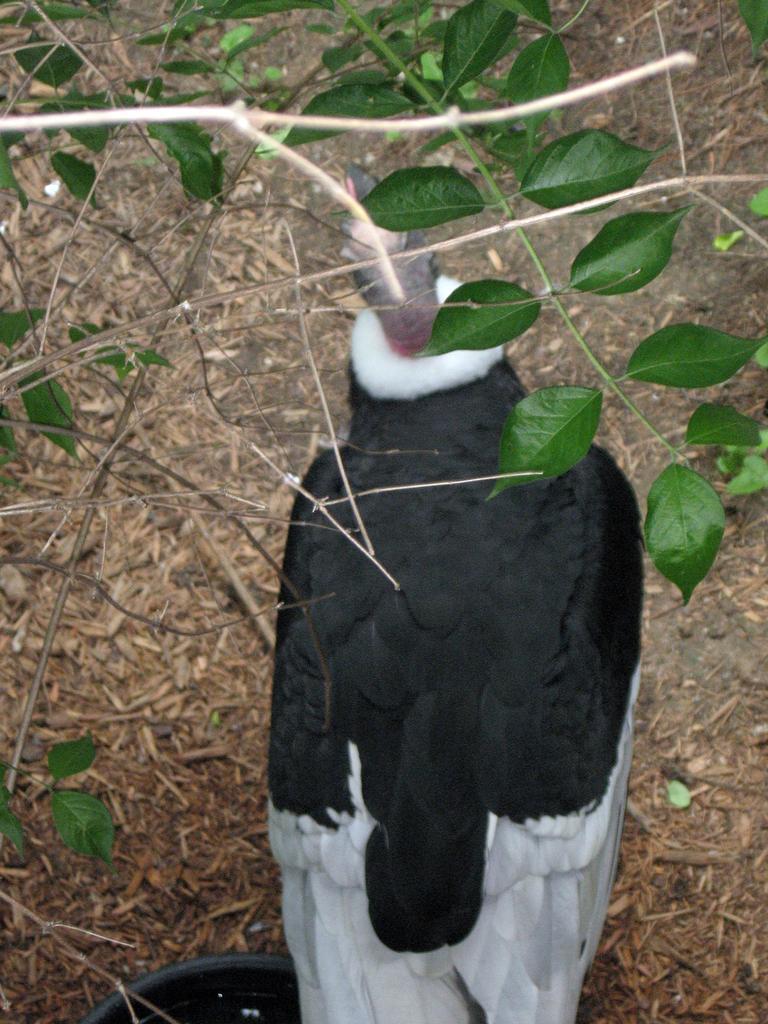Can you describe this image briefly? In the center of the image there is a bird. At the bottom of the image there is ground. There are plants with leaves. 